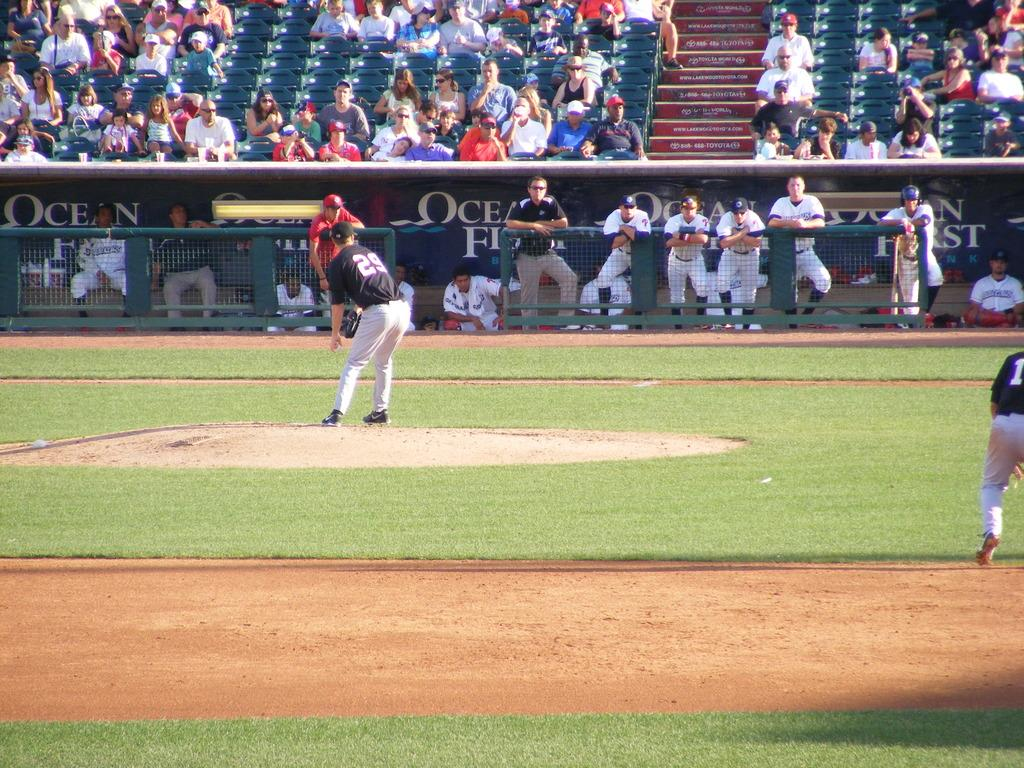<image>
Give a short and clear explanation of the subsequent image. Pitcher with number 29 is getting ready on the mound. 